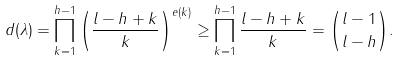<formula> <loc_0><loc_0><loc_500><loc_500>d ( \lambda ) = \prod _ { k = 1 } ^ { h - 1 } \left ( \frac { l - h + k } { k } \right ) ^ { e ( k ) } \geq \prod _ { k = 1 } ^ { h - 1 } \frac { l - h + k } { k } = \binom { l - 1 } { l - h } .</formula> 